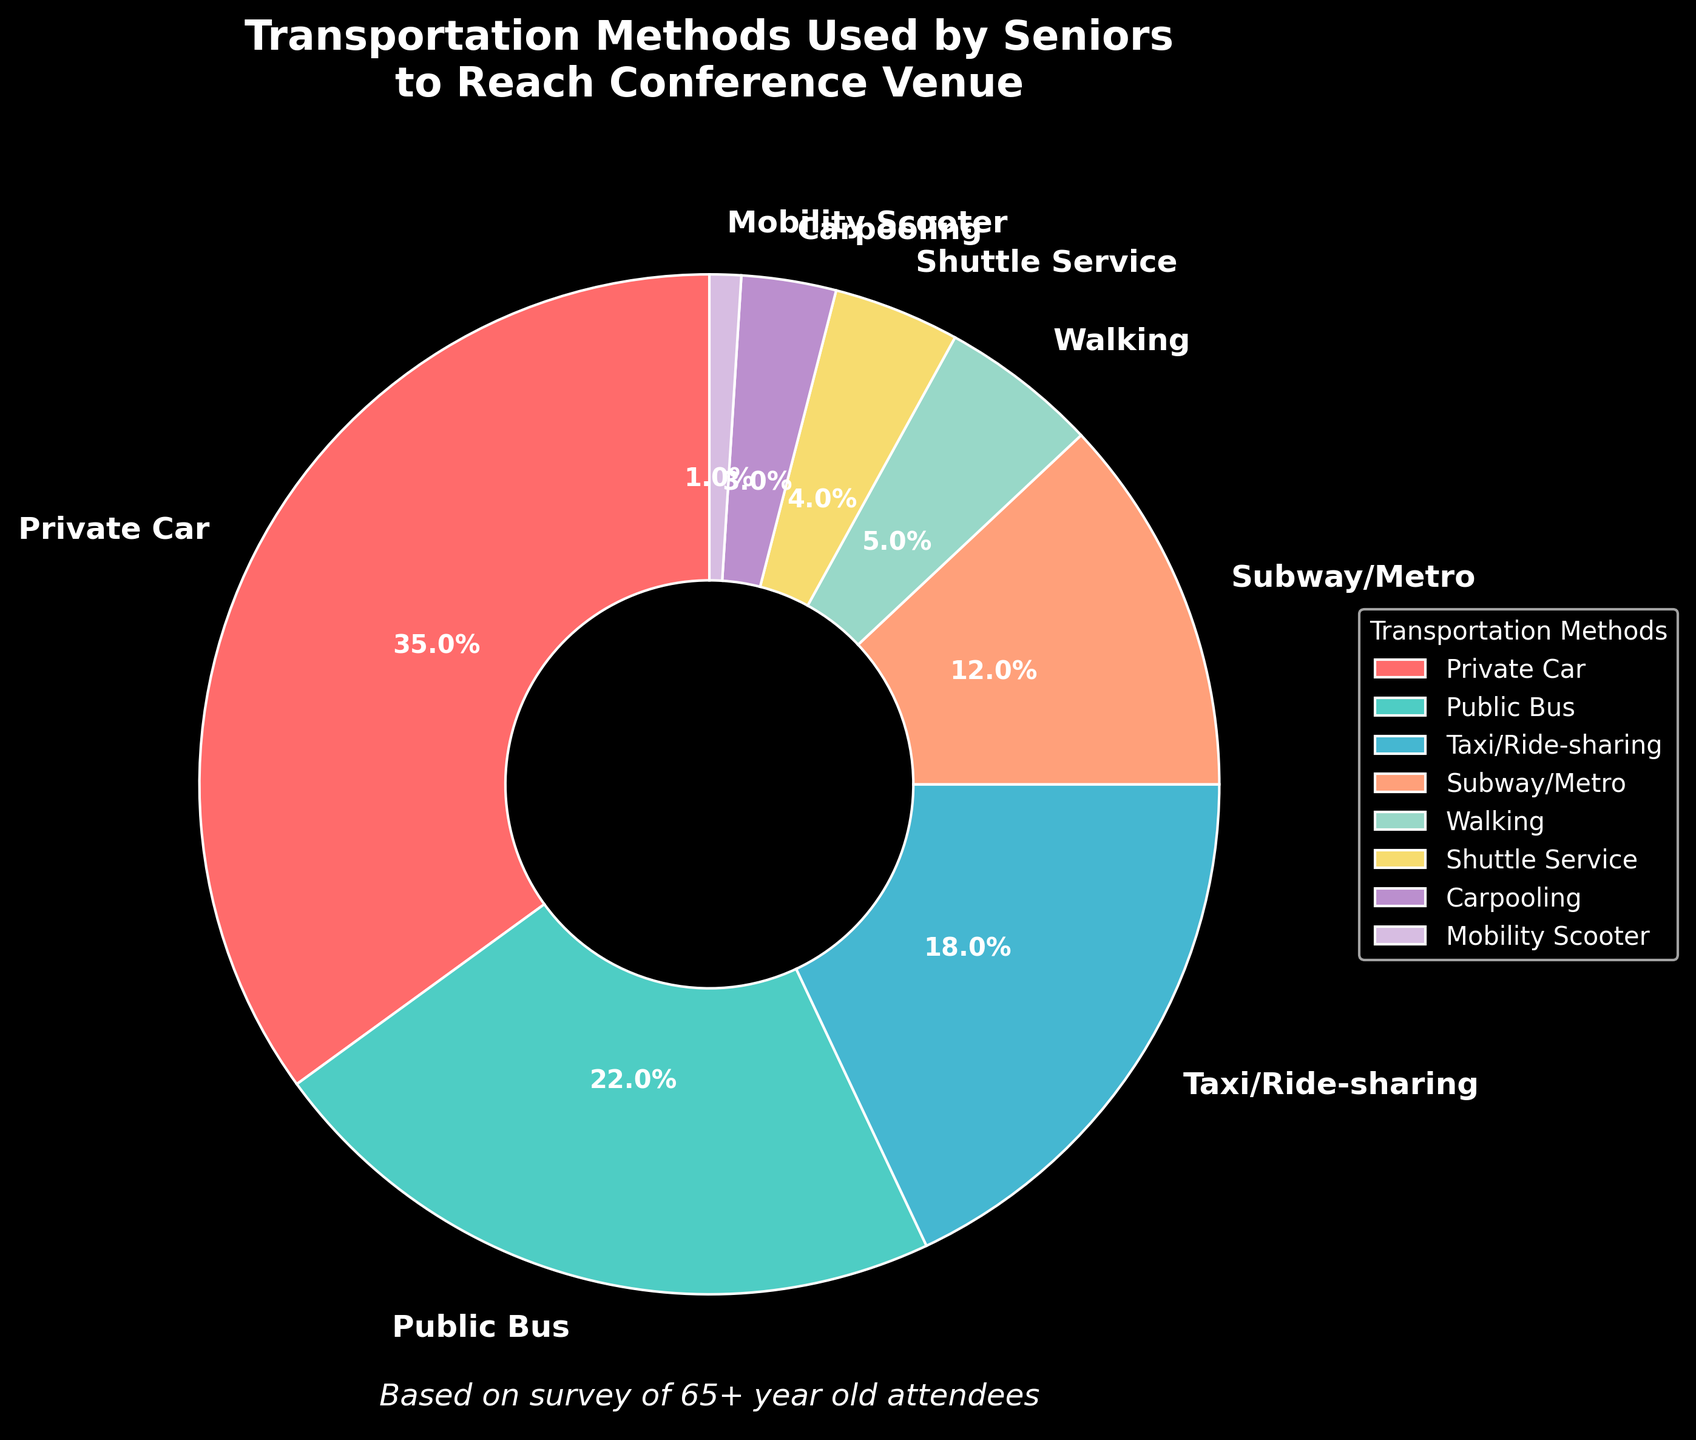What is the most commonly used transportation method by seniors to reach the conference venue? The pie chart shows the different transportation methods and their respective percentages. The largest section represents the most commonly used method.
Answer: Private Car What is the sum of the percentages of seniors who use Private Car and Public Bus to reach the conference venue? The percentages for Private Car and Public Bus are 35% and 22% respectively. Adding them together: 35 + 22 = 57%.
Answer: 57% Are there more seniors who prefer using Public Bus or Taxi/Ride-sharing? By comparing the two sections of the pie chart, you can see that Public Bus has a percentage of 22% while Taxi/Ride-sharing has a percentage of 18%.
Answer: Public Bus What transportation method has the smallest proportion of usage among seniors? The smallest section of the pie chart represents the least used transportation method. The section labeled "Mobility Scooter" has the smallest percentage of 1%.
Answer: Mobility Scooter How many transportation methods have usage percentages below 10%? Examine the pie chart and count the sections with percentages below 10%. The sections for Walking (5%), Shuttle Service (4%), Carpooling (3%), and Mobility Scooter (1%) visually meet this criterion.
Answer: 4 For which transportation methods are the combined percentages equal to the percentage of those who use Private Cars? The percentage for Private Cars is 35%. Check combinations of other sections. Public Bus (22%) + Taxi/Ride-sharing (18%) = 40% doesn't fit; Public Bus (22%) + Subway/Metro (12%) = 34% doesn't fit; Taxi/Ride-sharing (18%) + Subway/Metro (12%) + Walking (5%) = 35% fits.
Answer: Taxi/Ride-sharing + Subway/Metro + Walking Which two transportation methods have the closest percentages? Compare all sections. Public Bus (22%) and Taxi/Ride-sharing (18%) differ by 4%. Subway/Metro (12%) and Walking (5%) differ by more than 4%. Find the pair with the smallest difference.
Answer: Public Bus and Taxi/Ride-sharing Is the percentage of seniors who use Shuttle Service greater than the percentage of those who use Carpooling? By comparing the two sections of the pie chart, Shuttle Service has a percentage of 4% and Carpooling has a percentage of 3%.
Answer: Yes What is the total percentage of seniors using either Public Transport (Public Bus and Subway/Metro) or Ride-sharing services (Taxi/Ride-sharing and Carpooling)? Percentages are: Public Bus (22%), Subway/Metro (12%), Taxi/Ride-sharing (18%), Carpooling (3%). Adding them: 22 + 12 + 18 + 3 = 55%.
Answer: 55% What is the average percentage of the three least used transportation methods? The three least used methods are: Shuttle Service (4%), Carpooling (3%), and Mobility Scooter (1%). Their average is (4 + 3 + 1) / 3 = 2.67%.
Answer: 2.67% 